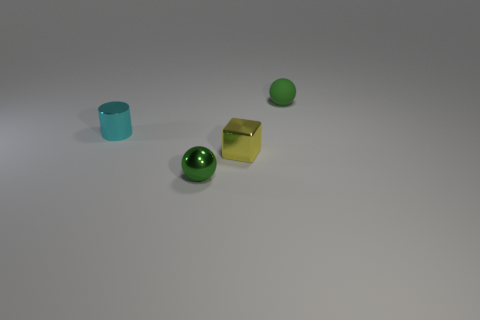What is the color of the tiny ball to the left of the small sphere that is behind the cylinder?
Provide a short and direct response. Green. Are there an equal number of cyan shiny objects in front of the metal ball and tiny green spheres that are in front of the tiny yellow object?
Offer a terse response. No. Is the material of the green ball that is in front of the cyan object the same as the cylinder?
Your answer should be compact. Yes. What is the color of the tiny object that is to the left of the tiny block and in front of the metal cylinder?
Make the answer very short. Green. There is a green object that is behind the tiny cyan metallic cylinder; what number of green metallic spheres are left of it?
Provide a short and direct response. 1. What material is the other green object that is the same shape as the small green matte thing?
Offer a very short reply. Metal. What is the color of the metallic sphere?
Your answer should be compact. Green. How many things are tiny yellow metal blocks or green metal spheres?
Provide a succinct answer. 2. What is the shape of the tiny green thing in front of the sphere that is behind the shiny cylinder?
Ensure brevity in your answer.  Sphere. What number of other objects are the same material as the tiny yellow cube?
Keep it short and to the point. 2. 